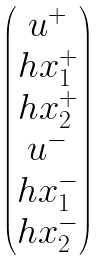Convert formula to latex. <formula><loc_0><loc_0><loc_500><loc_500>\begin{pmatrix} u ^ { + } \\ h x _ { 1 } ^ { + } \\ h x _ { 2 } ^ { + } \\ u ^ { - } \\ h x _ { 1 } ^ { - } \\ h x _ { 2 } ^ { - } \\ \end{pmatrix}</formula> 